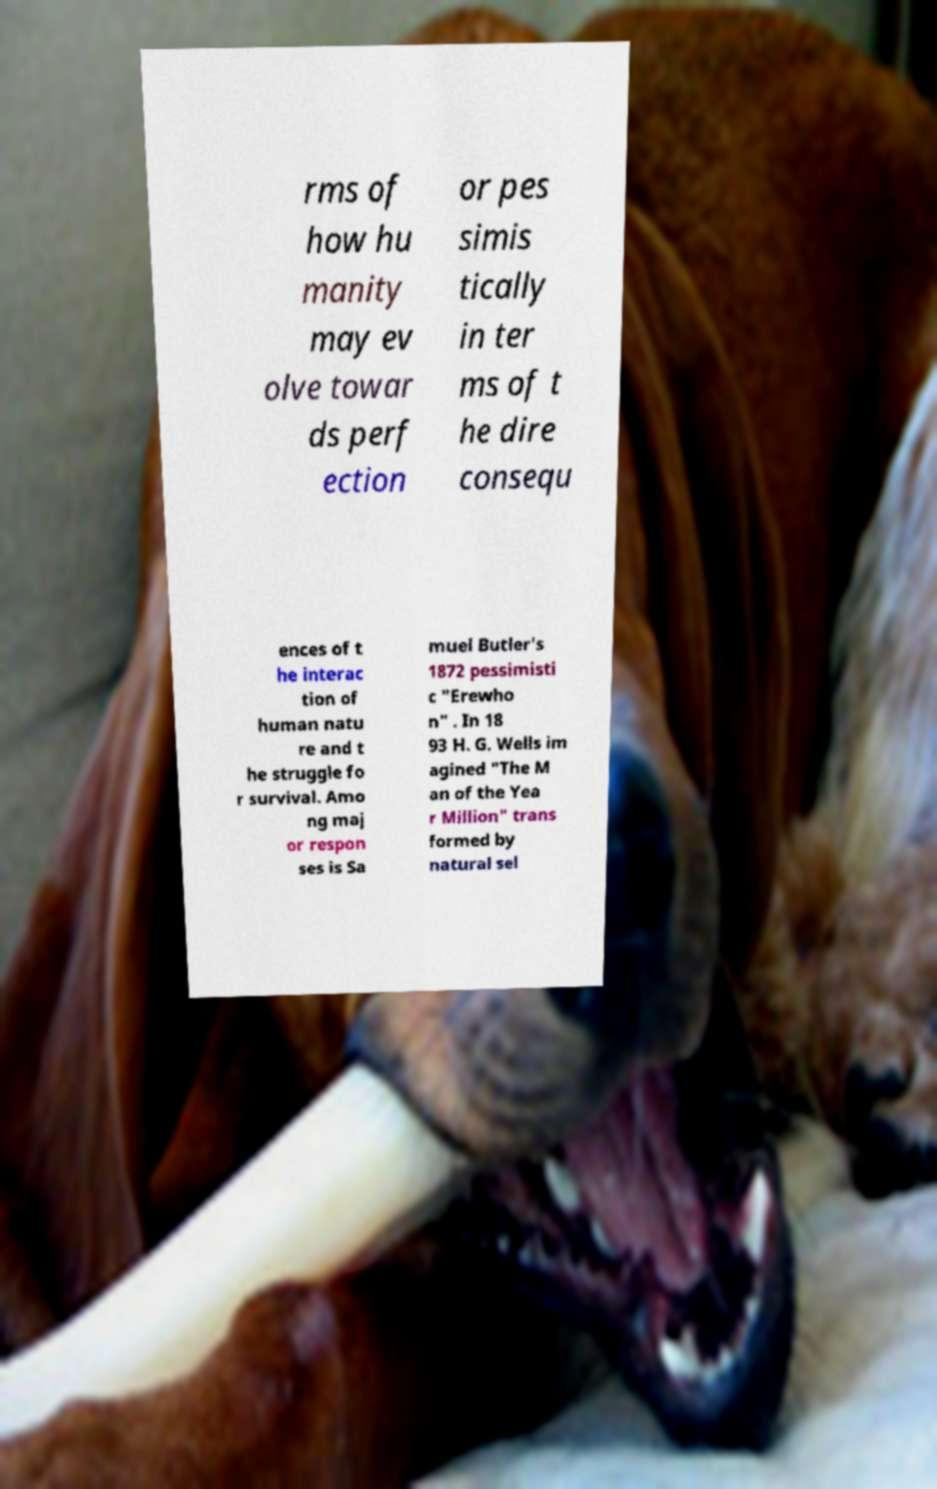For documentation purposes, I need the text within this image transcribed. Could you provide that? rms of how hu manity may ev olve towar ds perf ection or pes simis tically in ter ms of t he dire consequ ences of t he interac tion of human natu re and t he struggle fo r survival. Amo ng maj or respon ses is Sa muel Butler's 1872 pessimisti c "Erewho n" . In 18 93 H. G. Wells im agined "The M an of the Yea r Million" trans formed by natural sel 